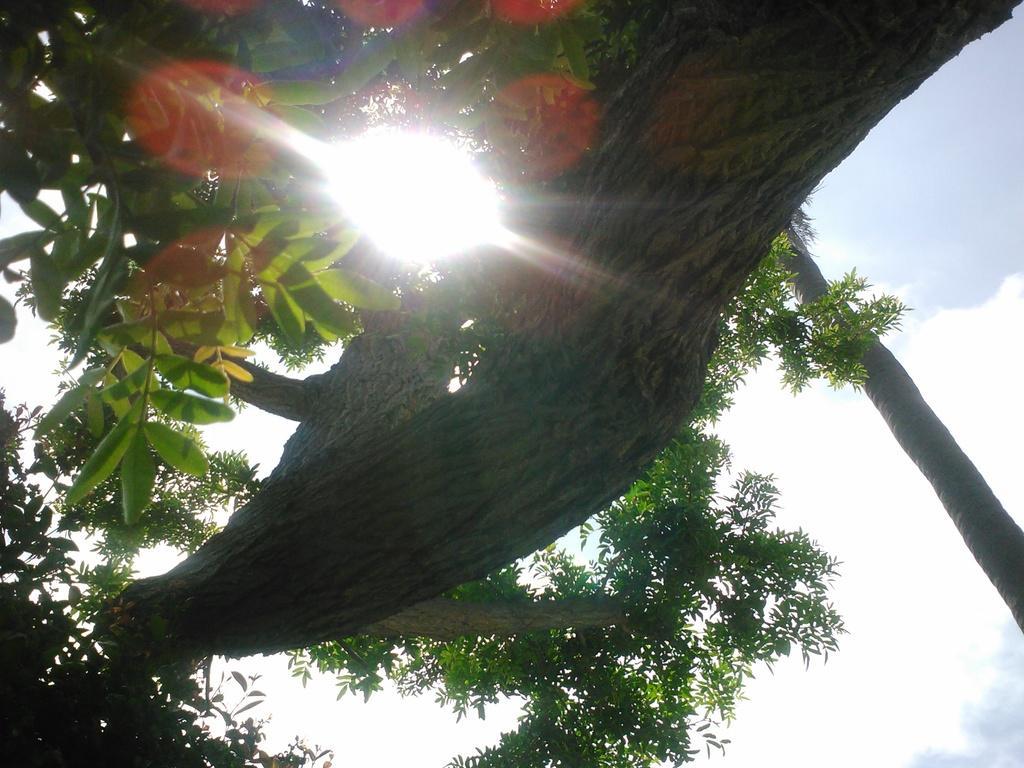Describe this image in one or two sentences. In this image I can see few trees in green color and the sky is in blue and white color and I can also see the sun light. 